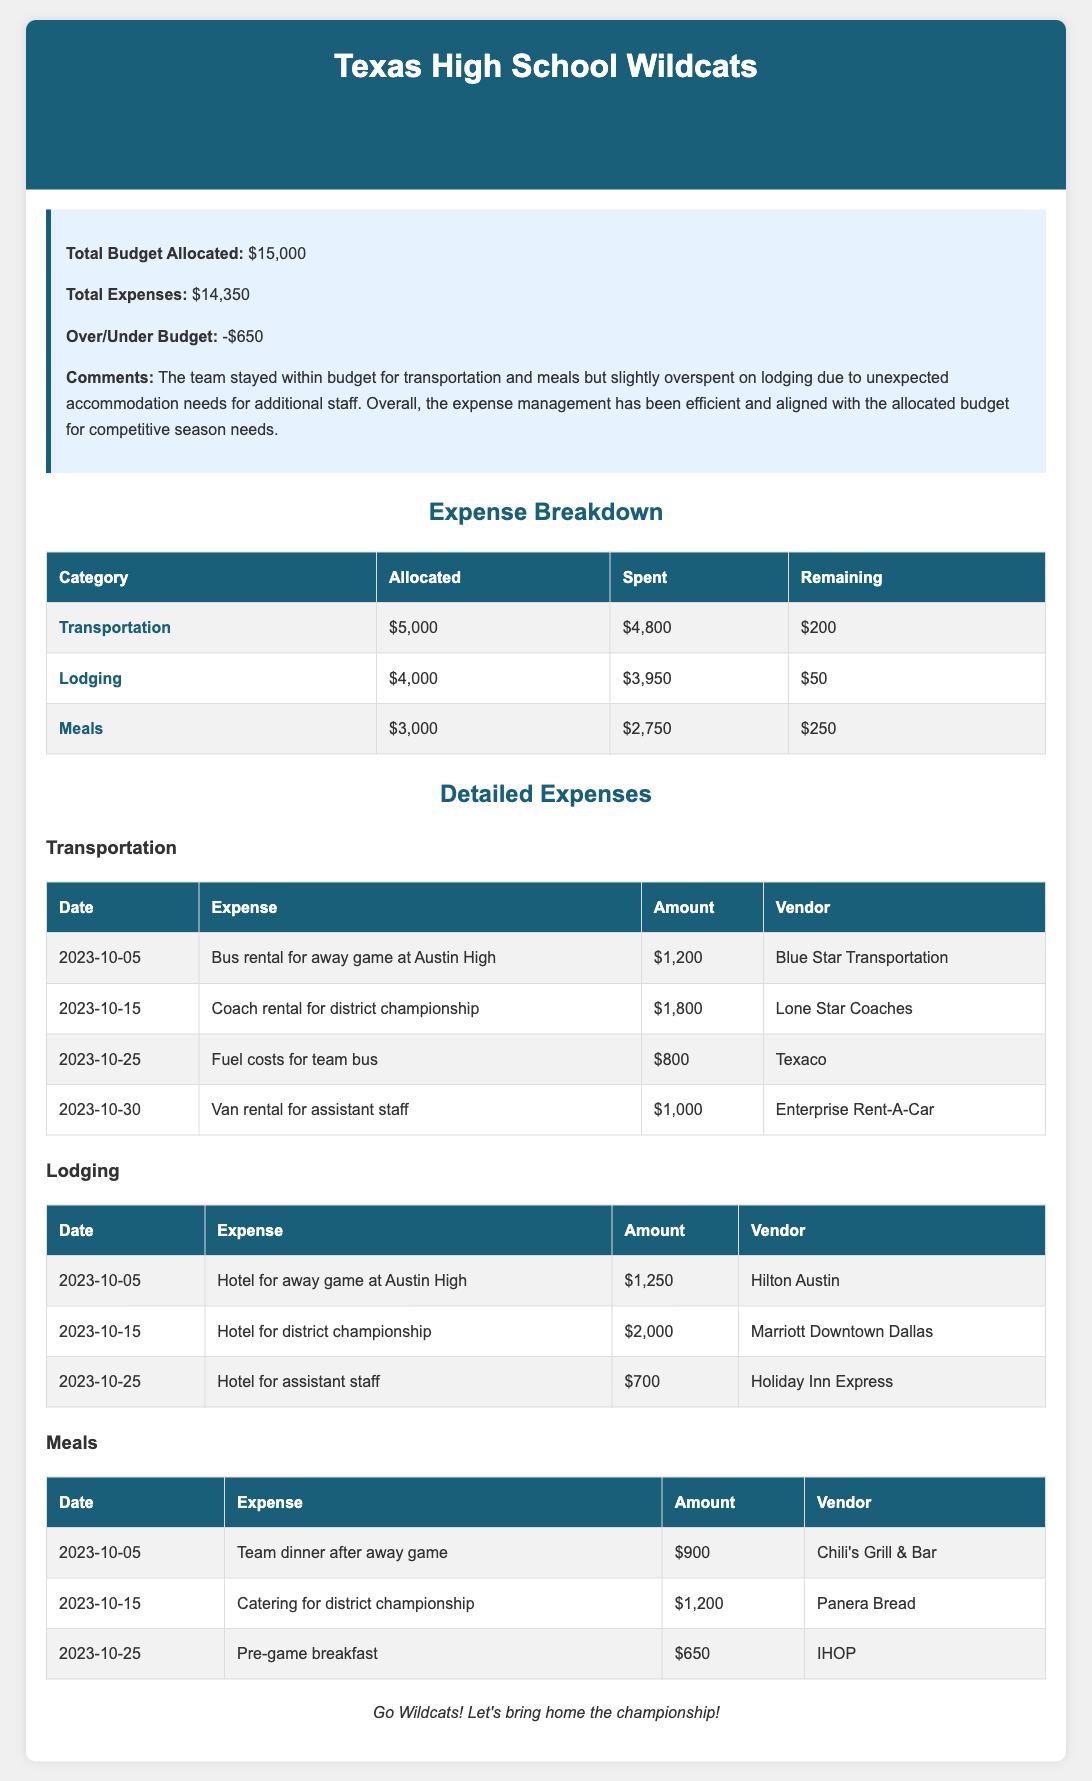What is the total budget allocated? The total budget allocated is stated in the summary section of the report.
Answer: $15,000 What is the amount spent on lodging? The spent amount for lodging can be found in the expense breakdown table.
Answer: $3,950 What is the remaining budget for meals? The remaining budget can be calculated from the expense breakdown for meals.
Answer: $250 Which vendor provided the team dinner after the away game? The specific vendor for the team dinner is listed in the detailed meals expenses section.
Answer: Chili's Grill & Bar On which date was the catering for the district championship? This information is recorded in the detailed meals expenses table under the respective date and expense.
Answer: 2023-10-15 What were the total expenses for the transportation category? The total expenses for transportation can be found in the expense breakdown table.
Answer: $4,800 How much was spent on fuel costs for the team bus? The expense for fuel costs is listed in the detailed transportation expenses table.
Answer: $800 What is the over/under budget amount? The over/under budget figure is provided in the summary part of the report.
Answer: -$650 What comment was made regarding lodging expenses? The comments section contains insights about expenses related to lodging.
Answer: Overspent on lodging due to unexpected accommodation needs 